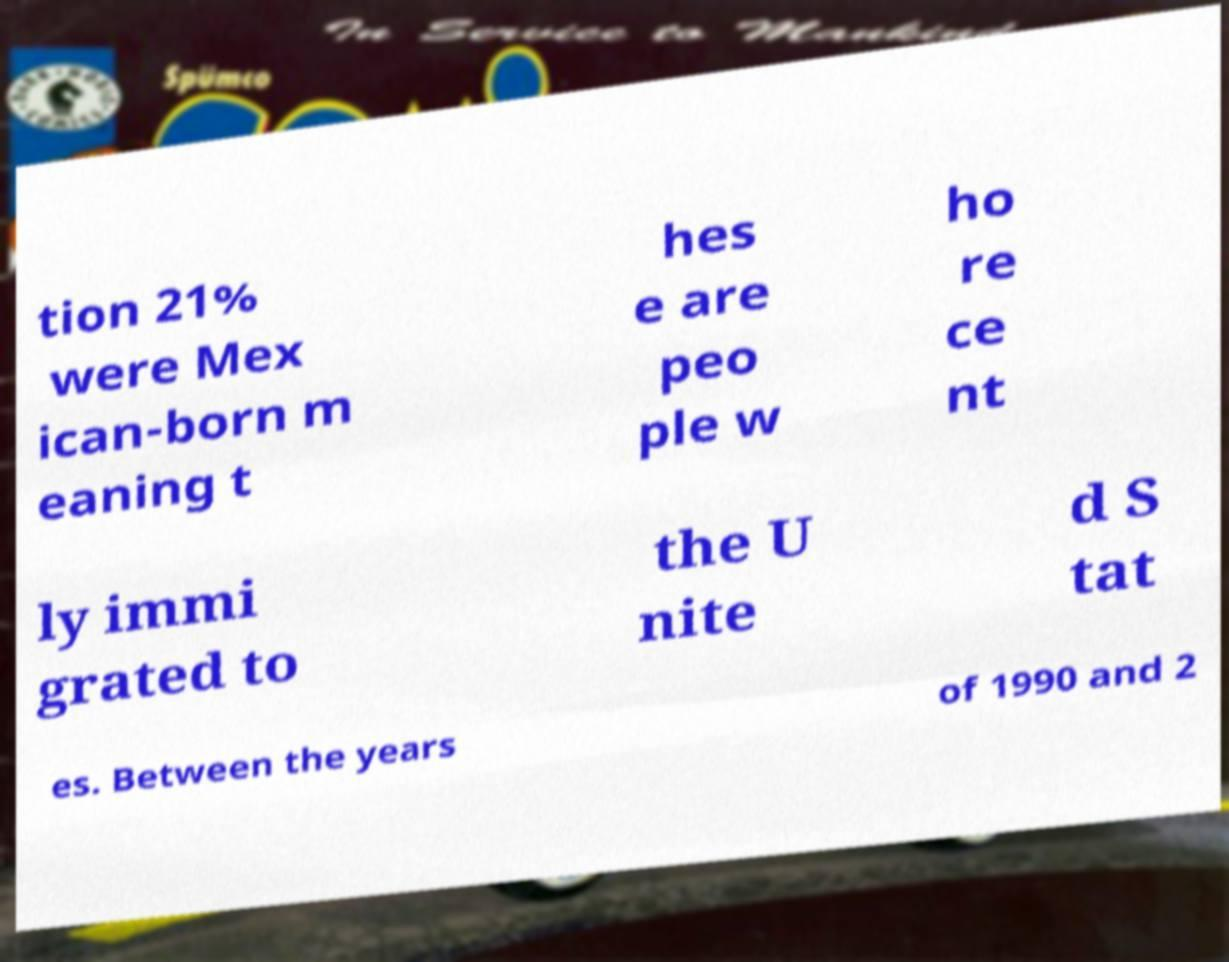Please read and relay the text visible in this image. What does it say? tion 21% were Mex ican-born m eaning t hes e are peo ple w ho re ce nt ly immi grated to the U nite d S tat es. Between the years of 1990 and 2 